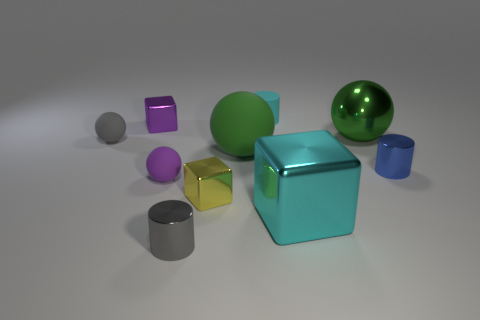Subtract all tiny cubes. How many cubes are left? 1 Subtract all red cylinders. How many green balls are left? 2 Subtract all green spheres. How many spheres are left? 2 Subtract all cubes. How many objects are left? 7 Subtract all yellow metallic things. Subtract all small yellow shiny things. How many objects are left? 8 Add 1 large rubber objects. How many large rubber objects are left? 2 Add 5 big purple rubber balls. How many big purple rubber balls exist? 5 Subtract 0 blue spheres. How many objects are left? 10 Subtract all brown balls. Subtract all green cylinders. How many balls are left? 4 